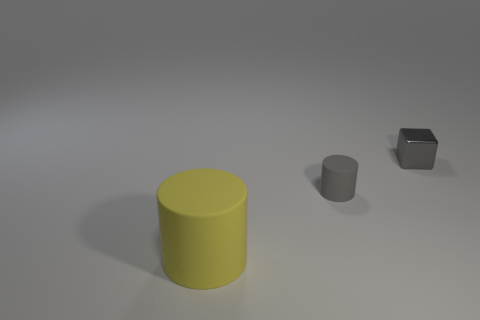There is a matte cylinder on the right side of the big yellow rubber object; is it the same size as the yellow rubber cylinder that is on the left side of the metal cube?
Offer a very short reply. No. There is a small matte object that is in front of the gray shiny cube; is there a small matte object that is on the right side of it?
Your response must be concise. No. There is a big thing; how many large matte objects are right of it?
Provide a succinct answer. 0. How many other objects are the same color as the tiny block?
Your answer should be compact. 1. Is the number of big yellow objects to the right of the metal object less than the number of yellow matte cylinders that are behind the tiny gray rubber object?
Your response must be concise. No. What number of objects are gray things that are in front of the tiny shiny block or small red metallic cylinders?
Make the answer very short. 1. Do the gray rubber cylinder and the cylinder in front of the small gray cylinder have the same size?
Make the answer very short. No. There is a gray thing that is the same shape as the big yellow thing; what is its size?
Offer a very short reply. Small. How many tiny gray metal things are on the right side of the object that is behind the tiny gray thing that is left of the gray metal block?
Your answer should be very brief. 0. What number of cubes are either shiny things or tiny gray rubber things?
Offer a very short reply. 1. 